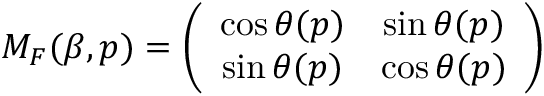<formula> <loc_0><loc_0><loc_500><loc_500>M _ { F } ( \beta , p ) = \left ( \begin{array} { c c } { \cos \theta ( p ) } & { \sin \theta ( p ) } \\ { \sin \theta ( p ) } & { \cos \theta ( p ) } \end{array} \right )</formula> 